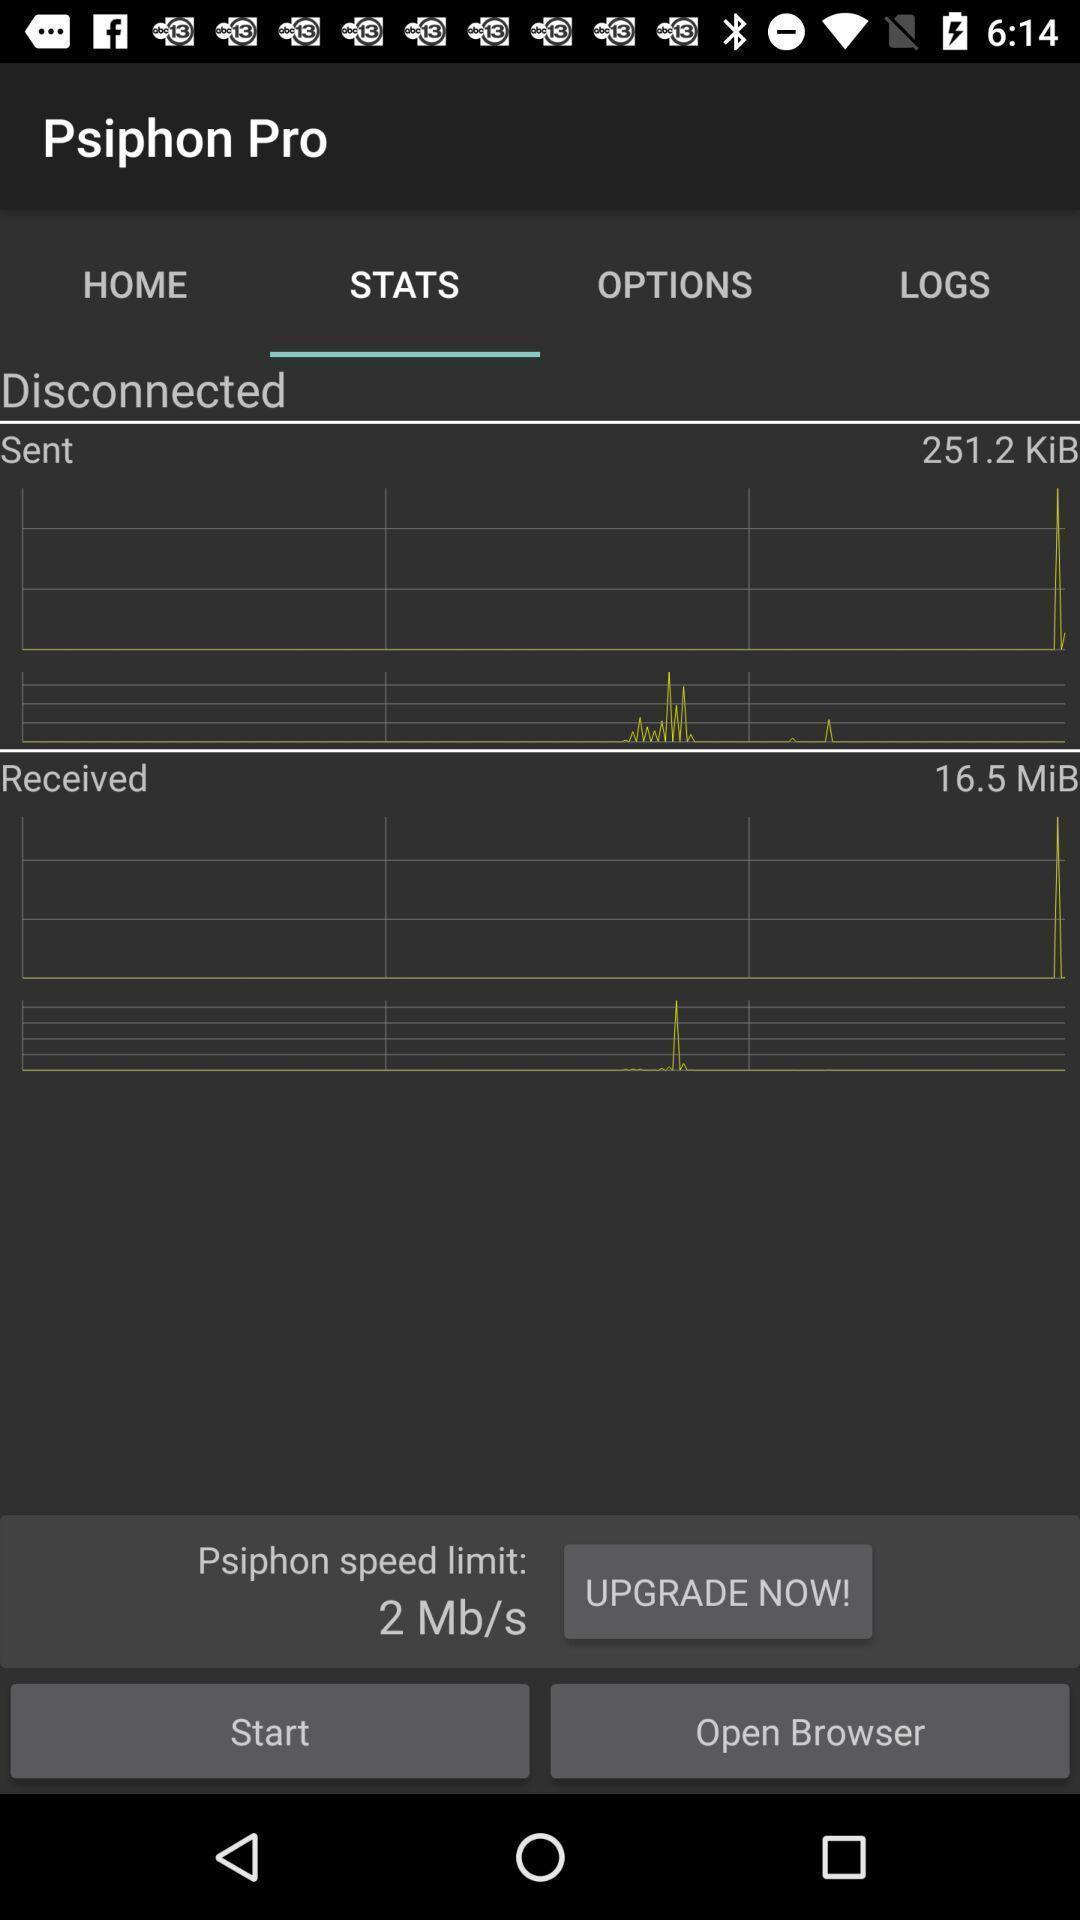Give me a narrative description of this picture. Page showing option like start. 